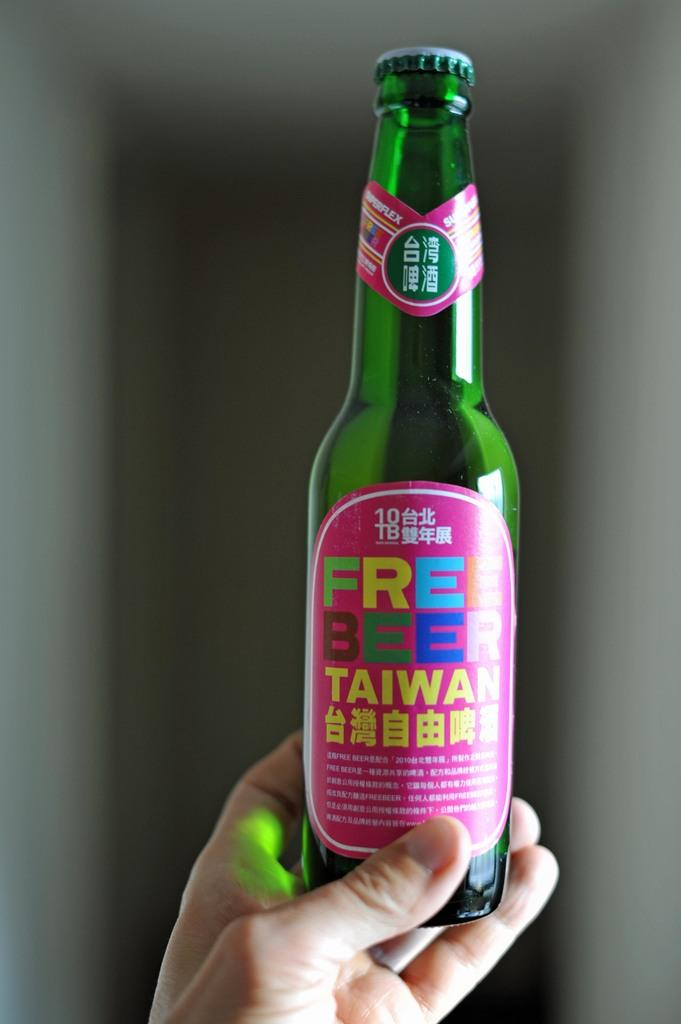What is the person in the image holding? The person is holding a bottle. What is written on the label of the bottle? The label on the bottle says 'FREE BEER'. What can be seen in the background of the image? There is a white color wall in the background of the image. Can you see any signs of an earthquake in the image? There is no indication of an earthquake in the image. Is the person in the image performing any magic tricks? There is no indication of magic tricks being performed in the image. 